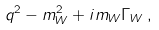<formula> <loc_0><loc_0><loc_500><loc_500>q ^ { 2 } - m _ { W } ^ { 2 } + i m _ { W } \Gamma _ { W } \, ,</formula> 